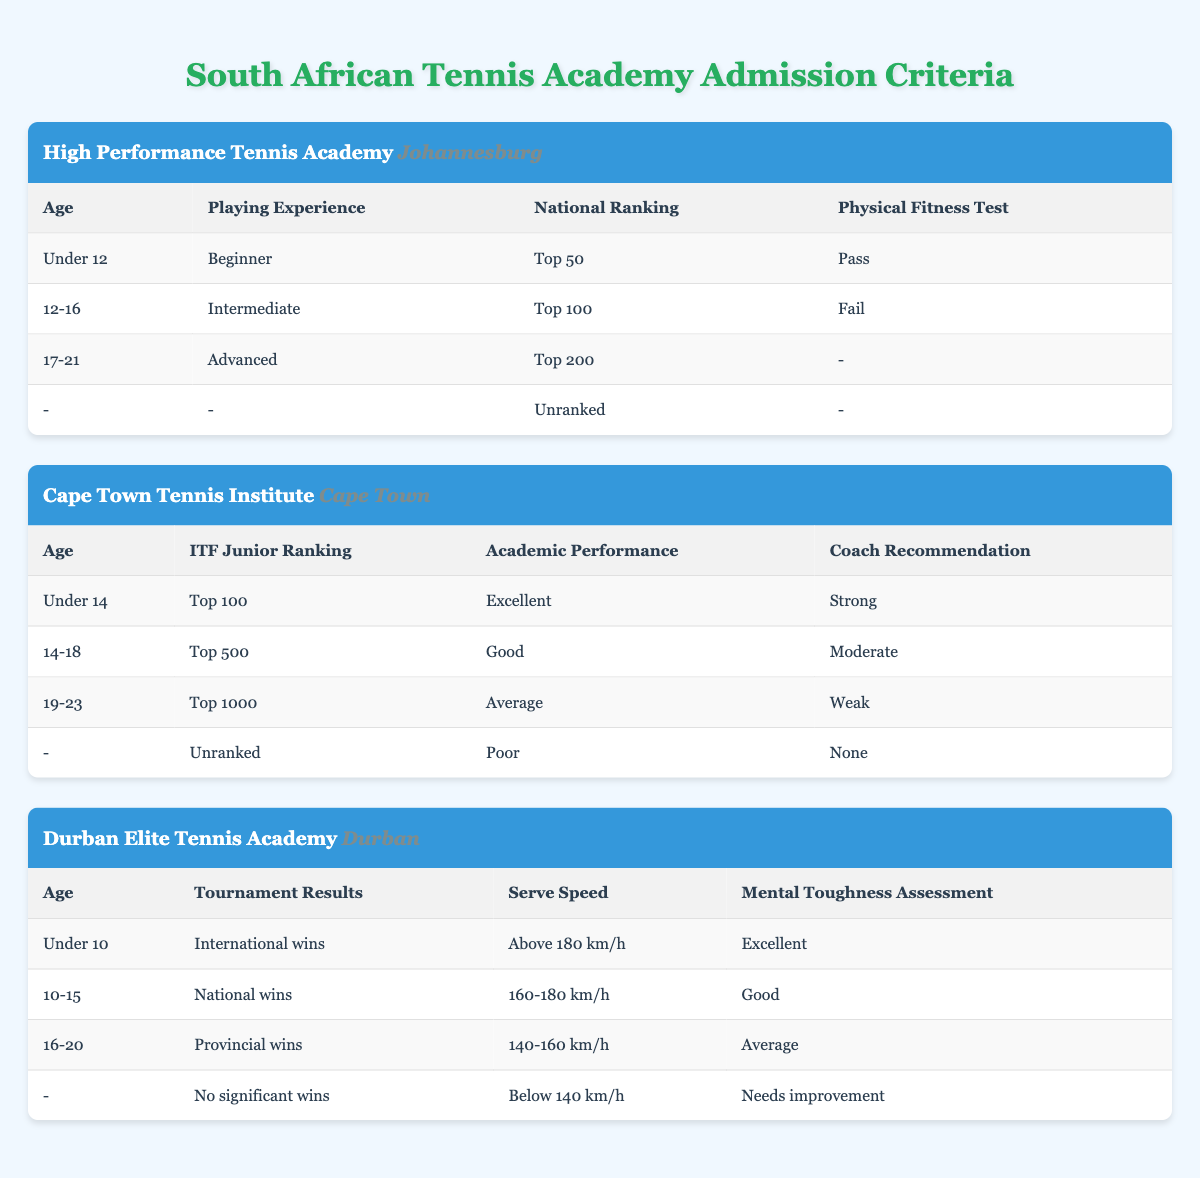What is the maximum age criterion for the High Performance Tennis Academy? The age criteria for the High Performance Tennis Academy are Under 12, 12-16, and 17-21. The maximum age from these options is 21, which corresponds to the '17-21' category.
Answer: 21 Is an applicant aged 15 eligible for the Cape Town Tennis Institute? The age criteria for the Cape Town Tennis Institute are Under 14, 14-18, and 19-23. Since 15 falls within the range of '14-18', an applicant aged 15 is eligible.
Answer: Yes What conditions must a player meet to be classified as 'Advanced' at the High Performance Tennis Academy? To be classified as 'Advanced' at the High Performance Tennis Academy, a player must be in the age range of '17-21', with 'Advanced' playing experience, and can have a national ranking of 'Top 200' or choose to be unranked. Physical fitness results are not specified for this classification.
Answer: Age: 17-21, Playing Experience: Advanced How many conditions exist for the evaluation of 'Academic Performance' at the Cape Town Tennis Institute? The Cape Town Tennis Institute has four conditions for 'Academic Performance': Excellent, Good, Average, and Poor. Thus, there are four distinct conditions under this criterion.
Answer: 4 At the Durban Elite Tennis Academy, what is the minimum serve speed needed for a positive assessment? The conditions for serve speed at the Durban Elite Tennis Academy include 'Above 180 km/h', '160-180 km/h', '140-160 km/h', and 'Below 140 km/h'. To receive a positive assessment, the minimum serve speed needed is '140 km/h', as that is the threshold for the 'Average' category.
Answer: 140 km/h Is there a specified qualifying condition for 'International wins' in the tournament results at the Durban Elite Tennis Academy? Yes, 'International wins' is listed as one of the conditions under the 'Tournament Results' criterion. Therefore, this criteria qualifies applicants at the top level of performance.
Answer: Yes What age group corresponds to the 'Excellent' mental toughness assessment in the Durban Elite Tennis Academy? For the Durban Elite Tennis Academy, 'Excellent' mental toughness assessment is required for players aged under 10, as seen in the first row of the table.
Answer: Under 10 How many students in the age category of 14-18 require a strong coach recommendation at the Cape Town Tennis Institute? Students aged 14-18 at the Cape Town Tennis Institute can fall under either 'Top 100' with 'Strong' coach recommendation or 'Top 500' with a 'Moderate' recommendation. Therefore, at least one student meeting the 'Strong' criterion is present among 14-18 age group students.
Answer: At least 1 student 